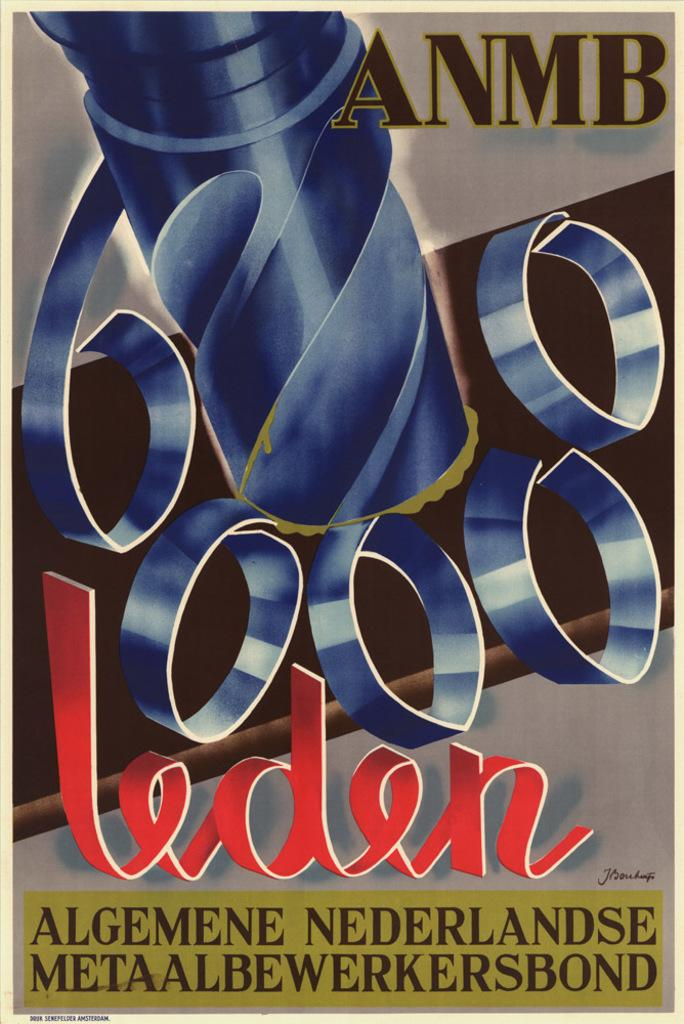<image>
Share a concise interpretation of the image provided. A poster features a picture of a drill and the text "6000 leden". 